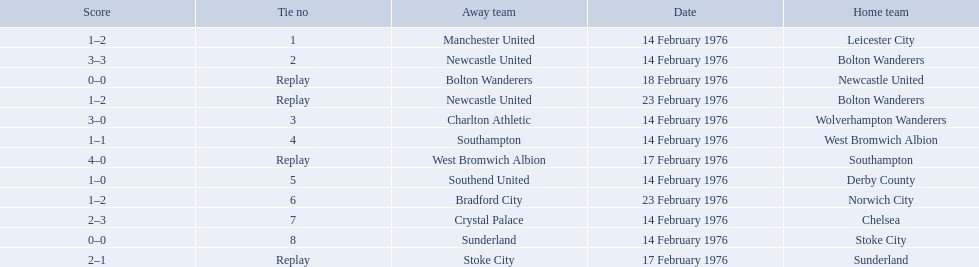What were the home teams in the 1975-76 fa cup? Leicester City, Bolton Wanderers, Newcastle United, Bolton Wanderers, Wolverhampton Wanderers, West Bromwich Albion, Southampton, Derby County, Norwich City, Chelsea, Stoke City, Sunderland. Which of these teams had the tie number 1? Leicester City. Can you parse all the data within this table? {'header': ['Score', 'Tie no', 'Away team', 'Date', 'Home team'], 'rows': [['1–2', '1', 'Manchester United', '14 February 1976', 'Leicester City'], ['3–3', '2', 'Newcastle United', '14 February 1976', 'Bolton Wanderers'], ['0–0', 'Replay', 'Bolton Wanderers', '18 February 1976', 'Newcastle United'], ['1–2', 'Replay', 'Newcastle United', '23 February 1976', 'Bolton Wanderers'], ['3–0', '3', 'Charlton Athletic', '14 February 1976', 'Wolverhampton Wanderers'], ['1–1', '4', 'Southampton', '14 February 1976', 'West Bromwich Albion'], ['4–0', 'Replay', 'West Bromwich Albion', '17 February 1976', 'Southampton'], ['1–0', '5', 'Southend United', '14 February 1976', 'Derby County'], ['1–2', '6', 'Bradford City', '23 February 1976', 'Norwich City'], ['2–3', '7', 'Crystal Palace', '14 February 1976', 'Chelsea'], ['0–0', '8', 'Sunderland', '14 February 1976', 'Stoke City'], ['2–1', 'Replay', 'Stoke City', '17 February 1976', 'Sunderland']]} 